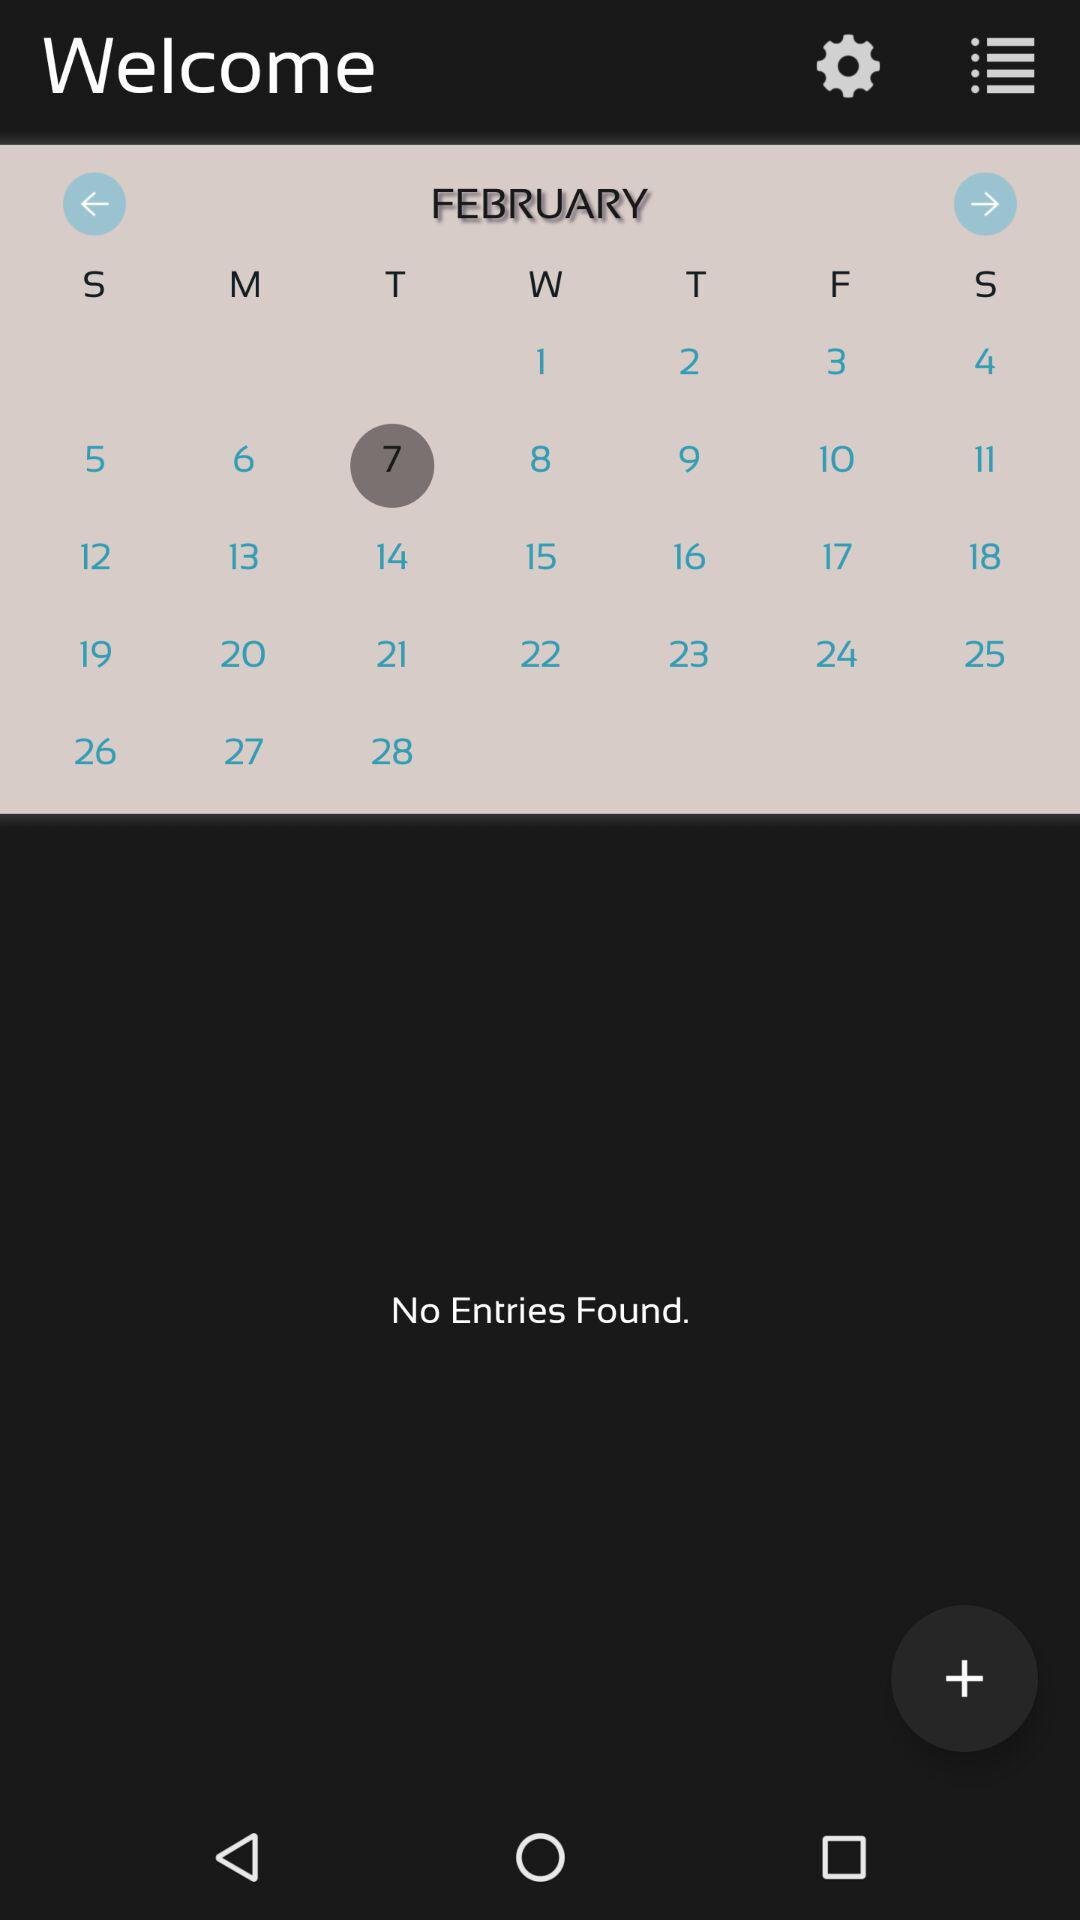Is there any entry? There are no entries. 